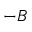<formula> <loc_0><loc_0><loc_500><loc_500>- B</formula> 